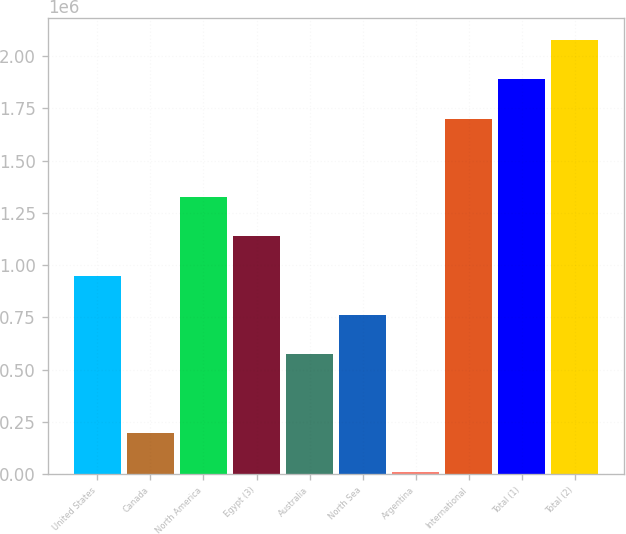Convert chart. <chart><loc_0><loc_0><loc_500><loc_500><bar_chart><fcel>United States<fcel>Canada<fcel>North America<fcel>Egypt (3)<fcel>Australia<fcel>North Sea<fcel>Argentina<fcel>International<fcel>Total (1)<fcel>Total (2)<nl><fcel>949308<fcel>197826<fcel>1.32505e+06<fcel>1.13718e+06<fcel>573567<fcel>761438<fcel>9956<fcel>1.70079e+06<fcel>1.88866e+06<fcel>2.07653e+06<nl></chart> 